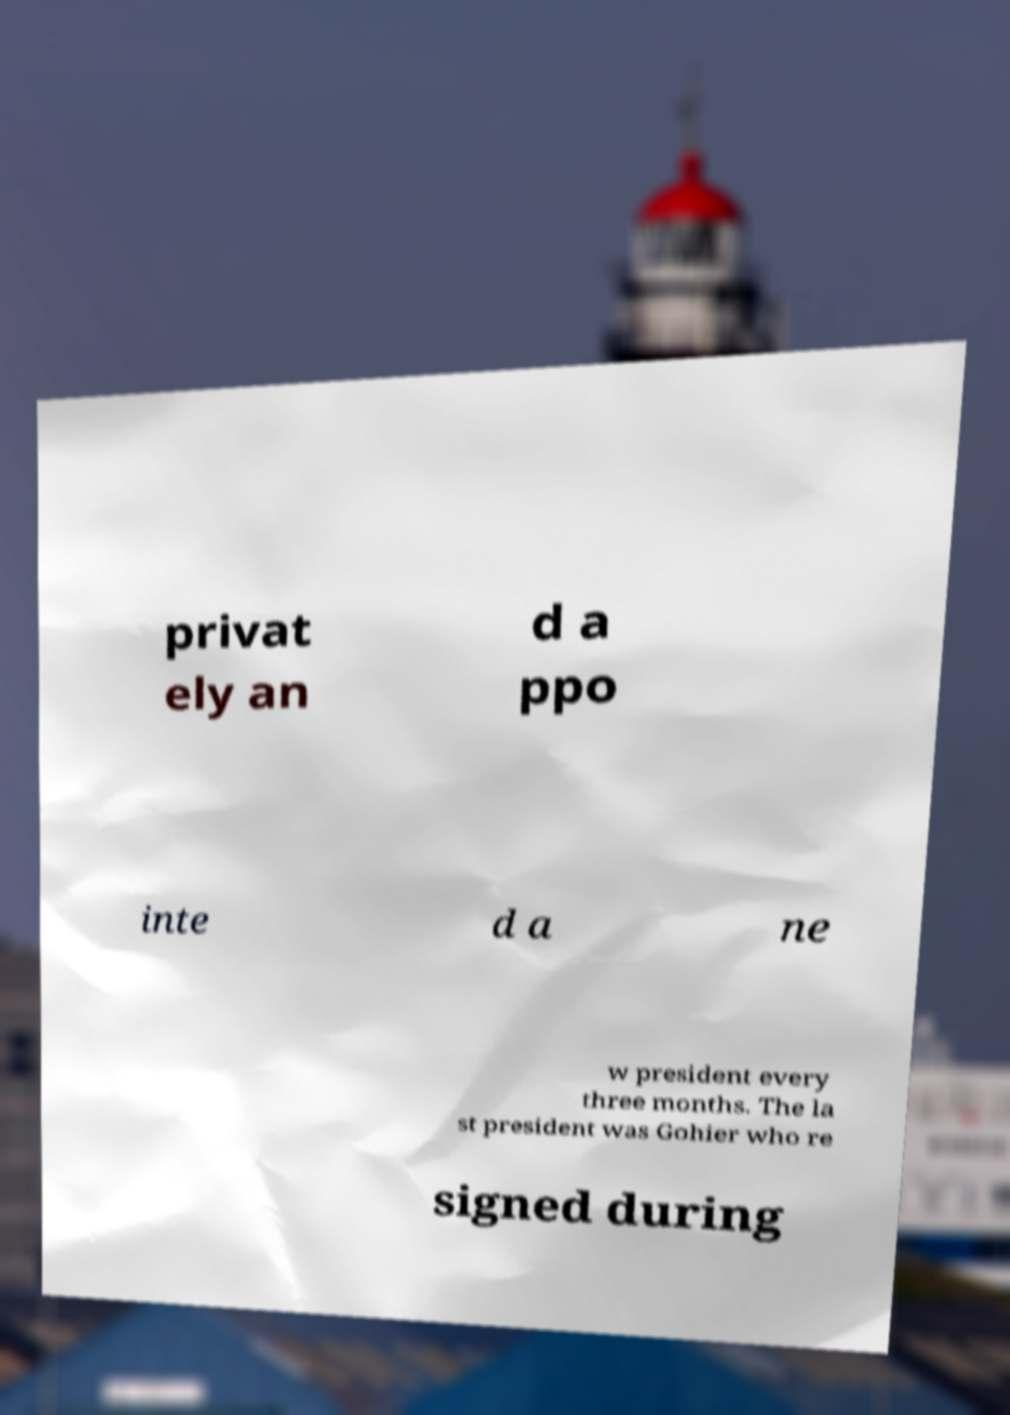There's text embedded in this image that I need extracted. Can you transcribe it verbatim? privat ely an d a ppo inte d a ne w president every three months. The la st president was Gohier who re signed during 